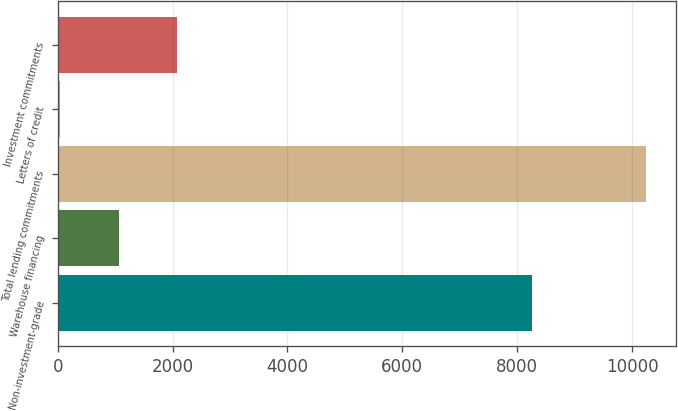Convert chart to OTSL. <chart><loc_0><loc_0><loc_500><loc_500><bar_chart><fcel>Non-investment-grade<fcel>Warehouse financing<fcel>Total lending commitments<fcel>Letters of credit<fcel>Investment commitments<nl><fcel>8255<fcel>1060.4<fcel>10244<fcel>40<fcel>2080.8<nl></chart> 